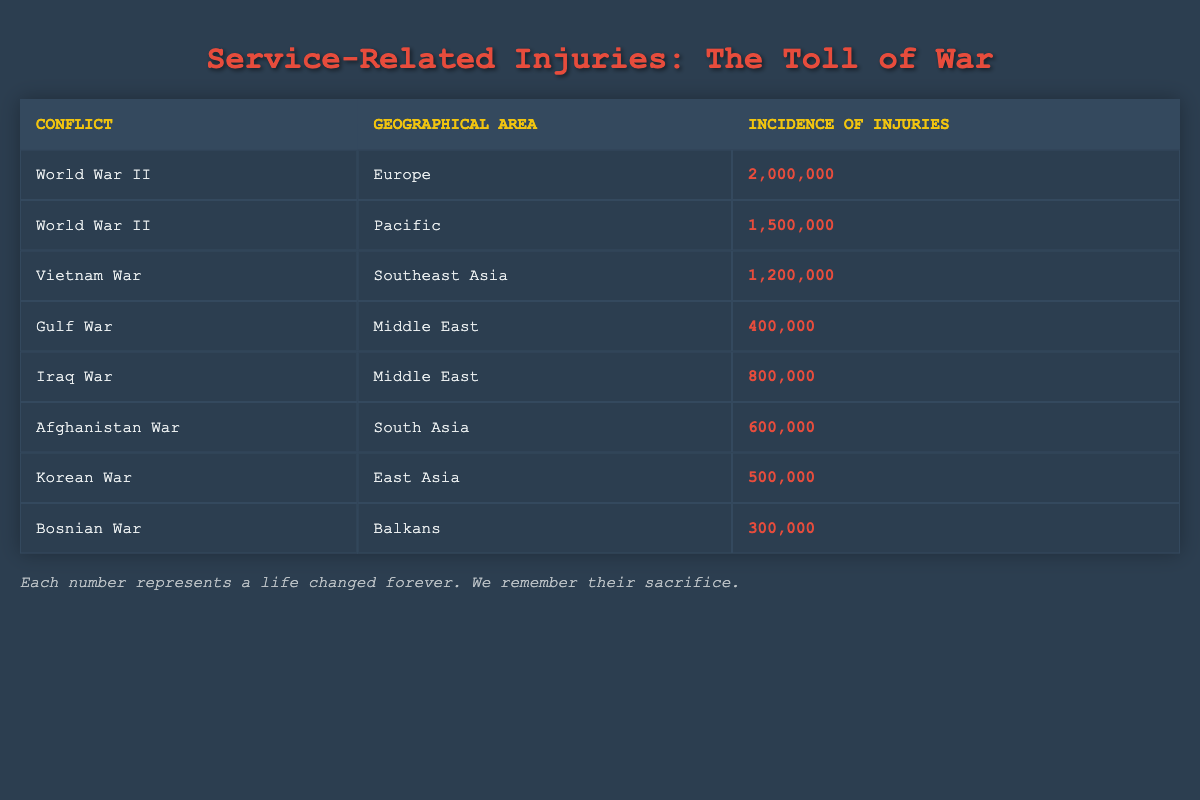What is the incidence of injuries in World War II in Europe? The table clearly shows that the incidence of injuries for World War II in Europe is listed as 2,000,000.
Answer: 2,000,000 Which geographical area had the highest incidence of injuries during World War II? Referring to the table, the two areas for World War II are Europe (2,000,000) and Pacific (1,500,000). Europe has the higher total.
Answer: Europe How many injuries were reported during the Gulf War? The table directly indicates that the incidence of injuries during the Gulf War is 400,000.
Answer: 400,000 What is the total incidence of injuries for conflicts taking place in the Middle East? Summing the Gulf War (400,000) and Iraq War (800,000), the total is 1,200,000. Thus, the calculation is 400,000 + 800,000 = 1,200,000.
Answer: 1,200,000 Is the incidence of injuries greater in the Afghan War than in the Korean War? According to the table, Afghanistan War has 600,000 injuries and Korean War has 500,000. Since 600,000 is greater than 500,000, the statement is true.
Answer: Yes Which conflict had the lowest incidence of injuries? From the data, the lowest incidence is found in the Bosnian War, which has 300,000 injuries compared to all other conflicts listed.
Answer: Bosnian War What is the average incidence of injuries across all conflicts listed? First, we sum all the incidences: 2,000,000 (WWII Europe) + 1,500,000 (WWII Pacific) + 1,200,000 (Vietnam) + 400,000 (Gulf) + 800,000 (Iraq) + 600,000 (Afghanistan) + 500,000 (Korea) + 300,000 (Bosnian) = 7,300,000. There are 8 conflicts, so the average = 7,300,000 / 8 = 912,500.
Answer: 912,500 How many conflicts listed have an incidence of injuries over 500,000? Counting from the table, the ones over 500,000 are: WWII in Europe (2,000,000), WWII in Pacific (1,500,000), Vietnam (1,200,000), Iraq (800,000), and Afghanistan (600,000). That totals to five conflicts.
Answer: 5 What is the difference in incidence of injuries between the Vietnam War and the Gulf War? The Vietnam War has 1,200,000 injuries and the Gulf War has 400,000 injuries. The difference is 1,200,000 - 400,000 = 800,000.
Answer: 800,000 